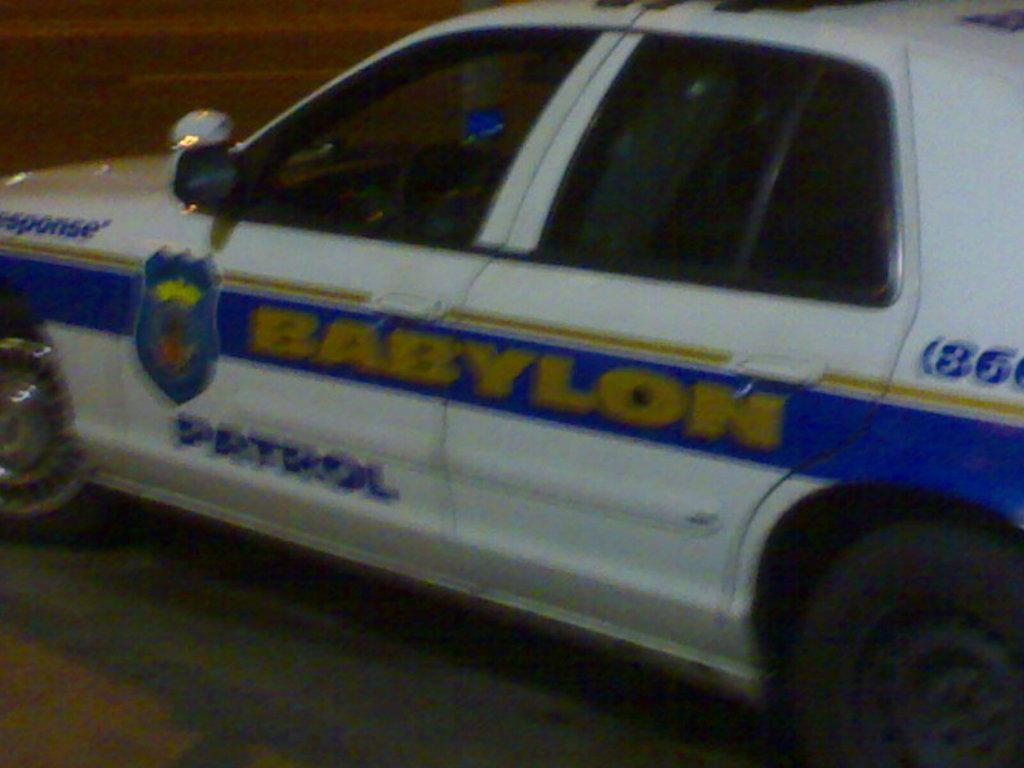<image>
Present a compact description of the photo's key features. A white car with a blue stripe says Babylon Patrol on the side. 